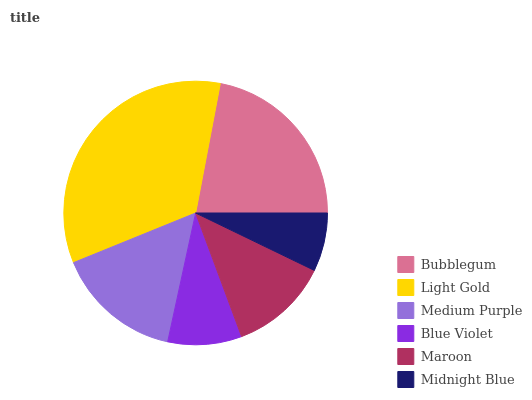Is Midnight Blue the minimum?
Answer yes or no. Yes. Is Light Gold the maximum?
Answer yes or no. Yes. Is Medium Purple the minimum?
Answer yes or no. No. Is Medium Purple the maximum?
Answer yes or no. No. Is Light Gold greater than Medium Purple?
Answer yes or no. Yes. Is Medium Purple less than Light Gold?
Answer yes or no. Yes. Is Medium Purple greater than Light Gold?
Answer yes or no. No. Is Light Gold less than Medium Purple?
Answer yes or no. No. Is Medium Purple the high median?
Answer yes or no. Yes. Is Maroon the low median?
Answer yes or no. Yes. Is Midnight Blue the high median?
Answer yes or no. No. Is Midnight Blue the low median?
Answer yes or no. No. 